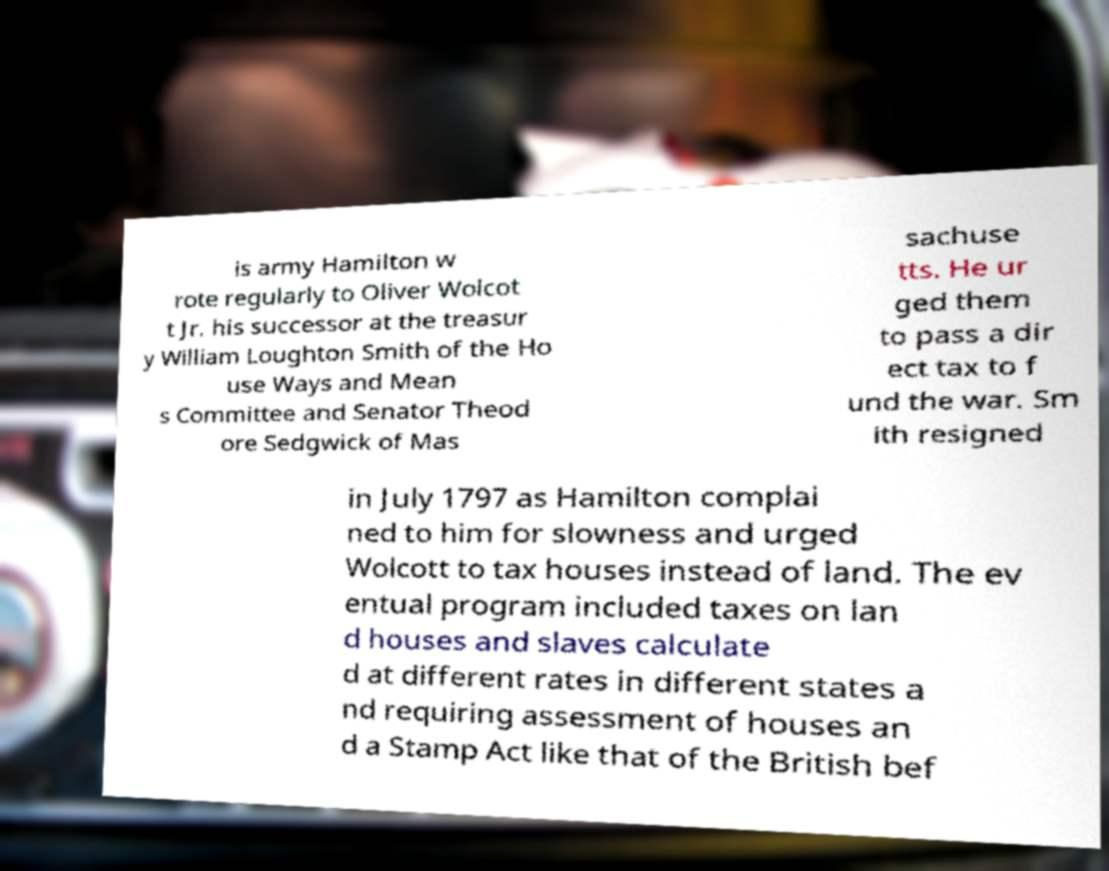There's text embedded in this image that I need extracted. Can you transcribe it verbatim? is army Hamilton w rote regularly to Oliver Wolcot t Jr. his successor at the treasur y William Loughton Smith of the Ho use Ways and Mean s Committee and Senator Theod ore Sedgwick of Mas sachuse tts. He ur ged them to pass a dir ect tax to f und the war. Sm ith resigned in July 1797 as Hamilton complai ned to him for slowness and urged Wolcott to tax houses instead of land. The ev entual program included taxes on lan d houses and slaves calculate d at different rates in different states a nd requiring assessment of houses an d a Stamp Act like that of the British bef 